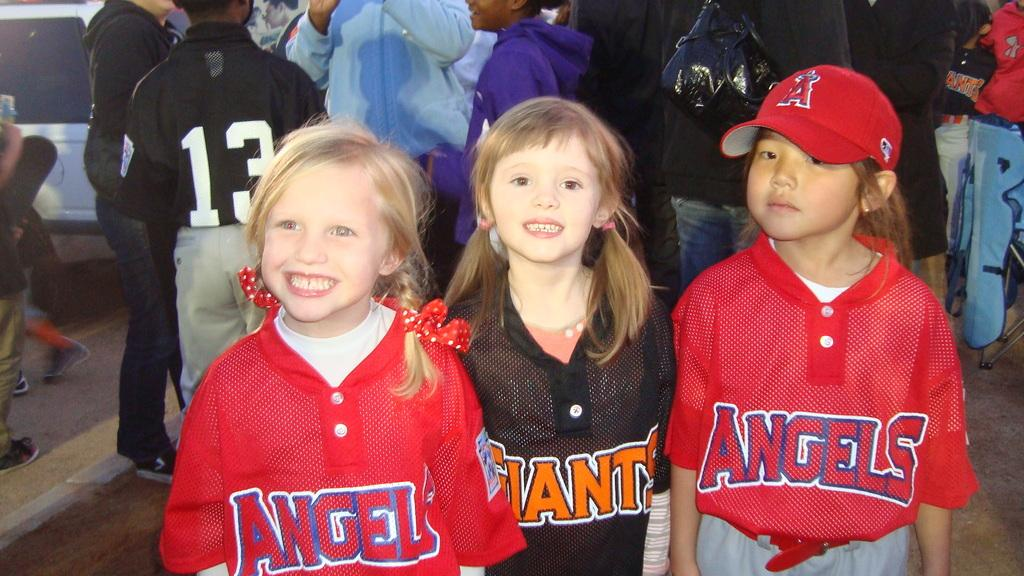<image>
Offer a succinct explanation of the picture presented. three little girls, 2 wearing red angels outfits and other wearing giants outfit 